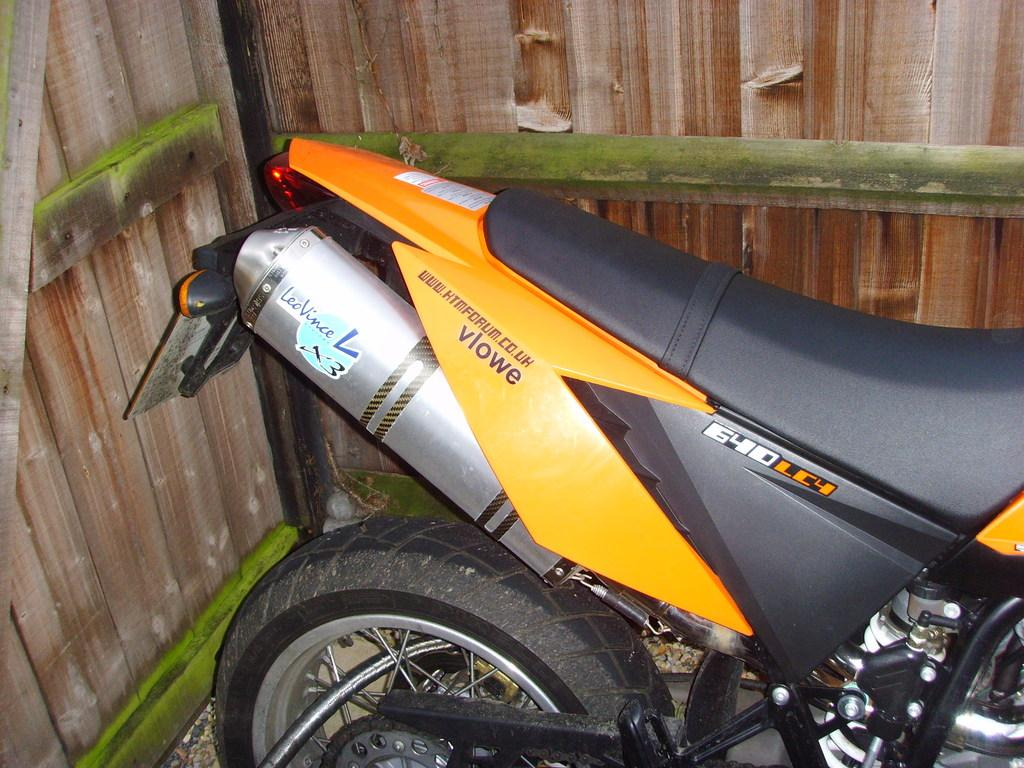What is the main subject of the image? The main subject of the image is a motorbike. Where is the motorbike located in the image? The motorbike is parked on a path in the image. What type of material can be seen behind the motorbike? There are wooden walls visible behind the motorbike. What type of net is being used to catch the brain in the image? There is no net or brain present in the image; it features a motorbike parked on a path with wooden walls in the background. 